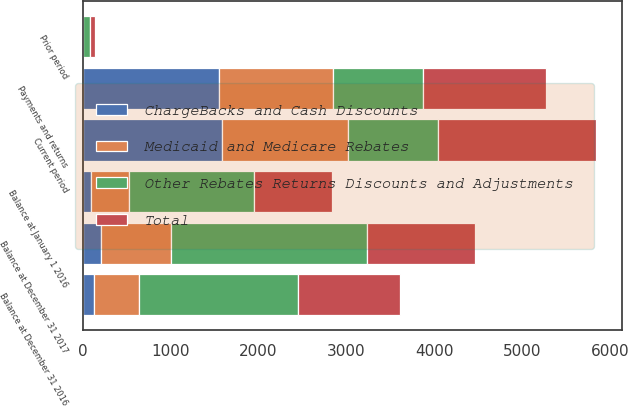Convert chart. <chart><loc_0><loc_0><loc_500><loc_500><stacked_bar_chart><ecel><fcel>Balance at January 1 2016<fcel>Current period<fcel>Payments and returns<fcel>Balance at December 31 2016<fcel>Prior period<fcel>Balance at December 31 2017<nl><fcel>ChargeBacks and Cash Discounts<fcel>97<fcel>1582<fcel>1553<fcel>126<fcel>3<fcel>209<nl><fcel>Medicaid and Medicare Rebates<fcel>434<fcel>1438<fcel>1296<fcel>520<fcel>4<fcel>796<nl><fcel>Total<fcel>890<fcel>1797<fcel>1397<fcel>1160<fcel>64<fcel>1228<nl><fcel>Other Rebates Returns Discounts and Adjustments<fcel>1421<fcel>1025<fcel>1025<fcel>1806<fcel>71<fcel>2233<nl></chart> 